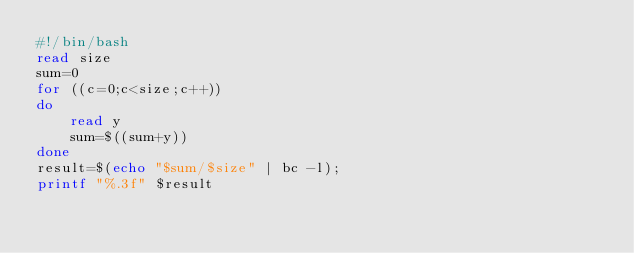Convert code to text. <code><loc_0><loc_0><loc_500><loc_500><_Bash_>#!/bin/bash
read size
sum=0
for ((c=0;c<size;c++))
do
    read y
    sum=$((sum+y))
done
result=$(echo "$sum/$size" | bc -l);
printf "%.3f" $result
</code> 